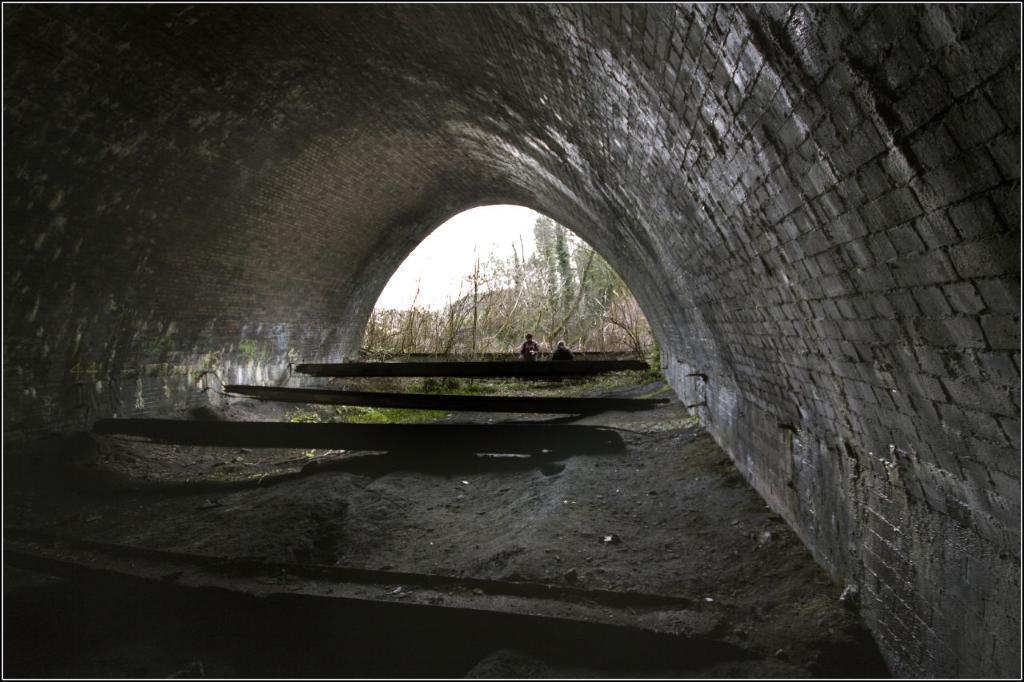In one or two sentences, can you explain what this image depicts? In this image we can see a tunnel, few objects on the ground and there are two persons, few trees and the sky in the background. 